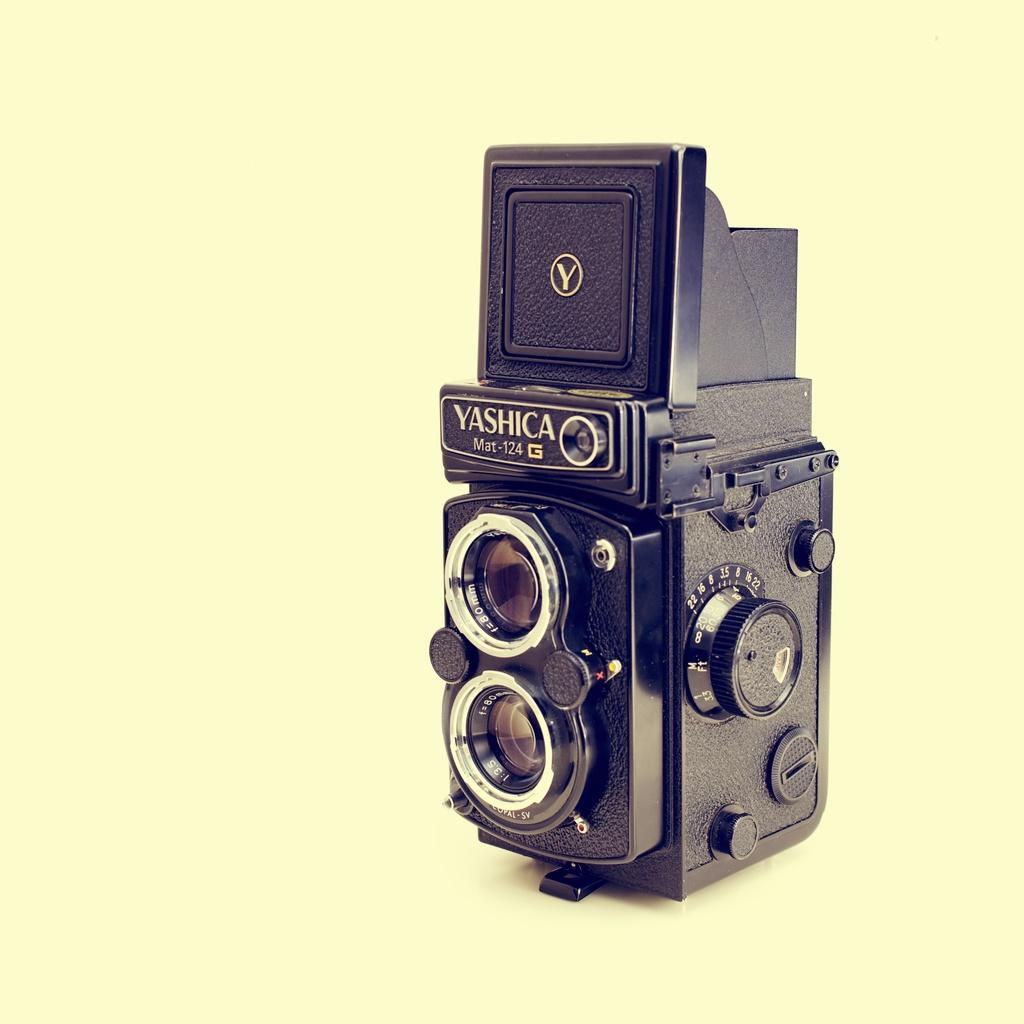What is the main subject of the image? The main subject of the image is a camera. Can you describe any specific features of the camera? Yes, the camera has two lenses. What color is the camera in the image? The camera is black in color. Can you tell me how many beetles are crawling on the camera in the image? There are no beetles present on the camera in the image. What type of camp can be seen set up near the camera in the image? There is no camp present near the camera in the image. 